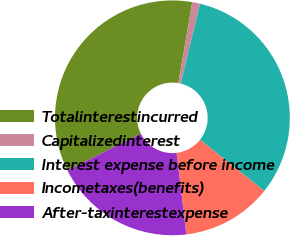<chart> <loc_0><loc_0><loc_500><loc_500><pie_chart><fcel>Totalinterestincurred<fcel>Capitalizedinterest<fcel>Interest expense before income<fcel>Incometaxes(benefits)<fcel>After-taxinterestexpense<nl><fcel>35.1%<fcel>1.08%<fcel>31.91%<fcel>12.41%<fcel>19.5%<nl></chart> 